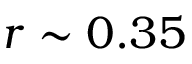<formula> <loc_0><loc_0><loc_500><loc_500>r \sim 0 . 3 5</formula> 